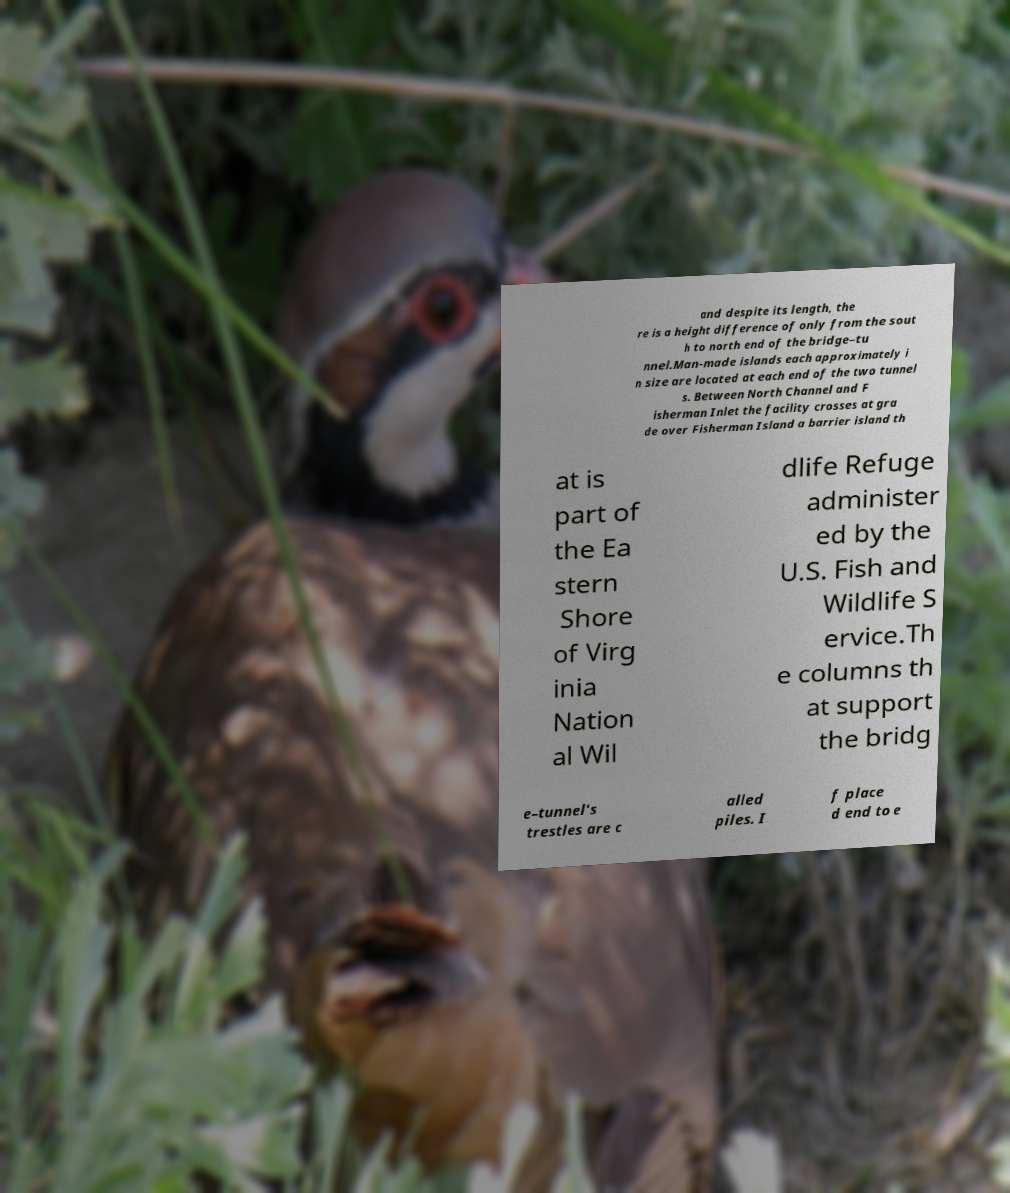Can you accurately transcribe the text from the provided image for me? and despite its length, the re is a height difference of only from the sout h to north end of the bridge–tu nnel.Man-made islands each approximately i n size are located at each end of the two tunnel s. Between North Channel and F isherman Inlet the facility crosses at gra de over Fisherman Island a barrier island th at is part of the Ea stern Shore of Virg inia Nation al Wil dlife Refuge administer ed by the U.S. Fish and Wildlife S ervice.Th e columns th at support the bridg e–tunnel's trestles are c alled piles. I f place d end to e 